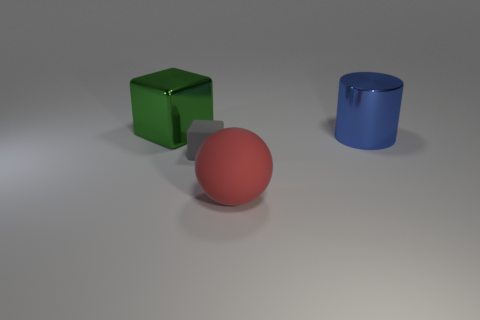Add 3 red matte things. How many objects exist? 7 Subtract all spheres. How many objects are left? 3 Subtract all yellow cubes. Subtract all blue objects. How many objects are left? 3 Add 4 big red balls. How many big red balls are left? 5 Add 4 large red matte balls. How many large red matte balls exist? 5 Subtract 0 red cubes. How many objects are left? 4 Subtract all brown balls. Subtract all purple blocks. How many balls are left? 1 